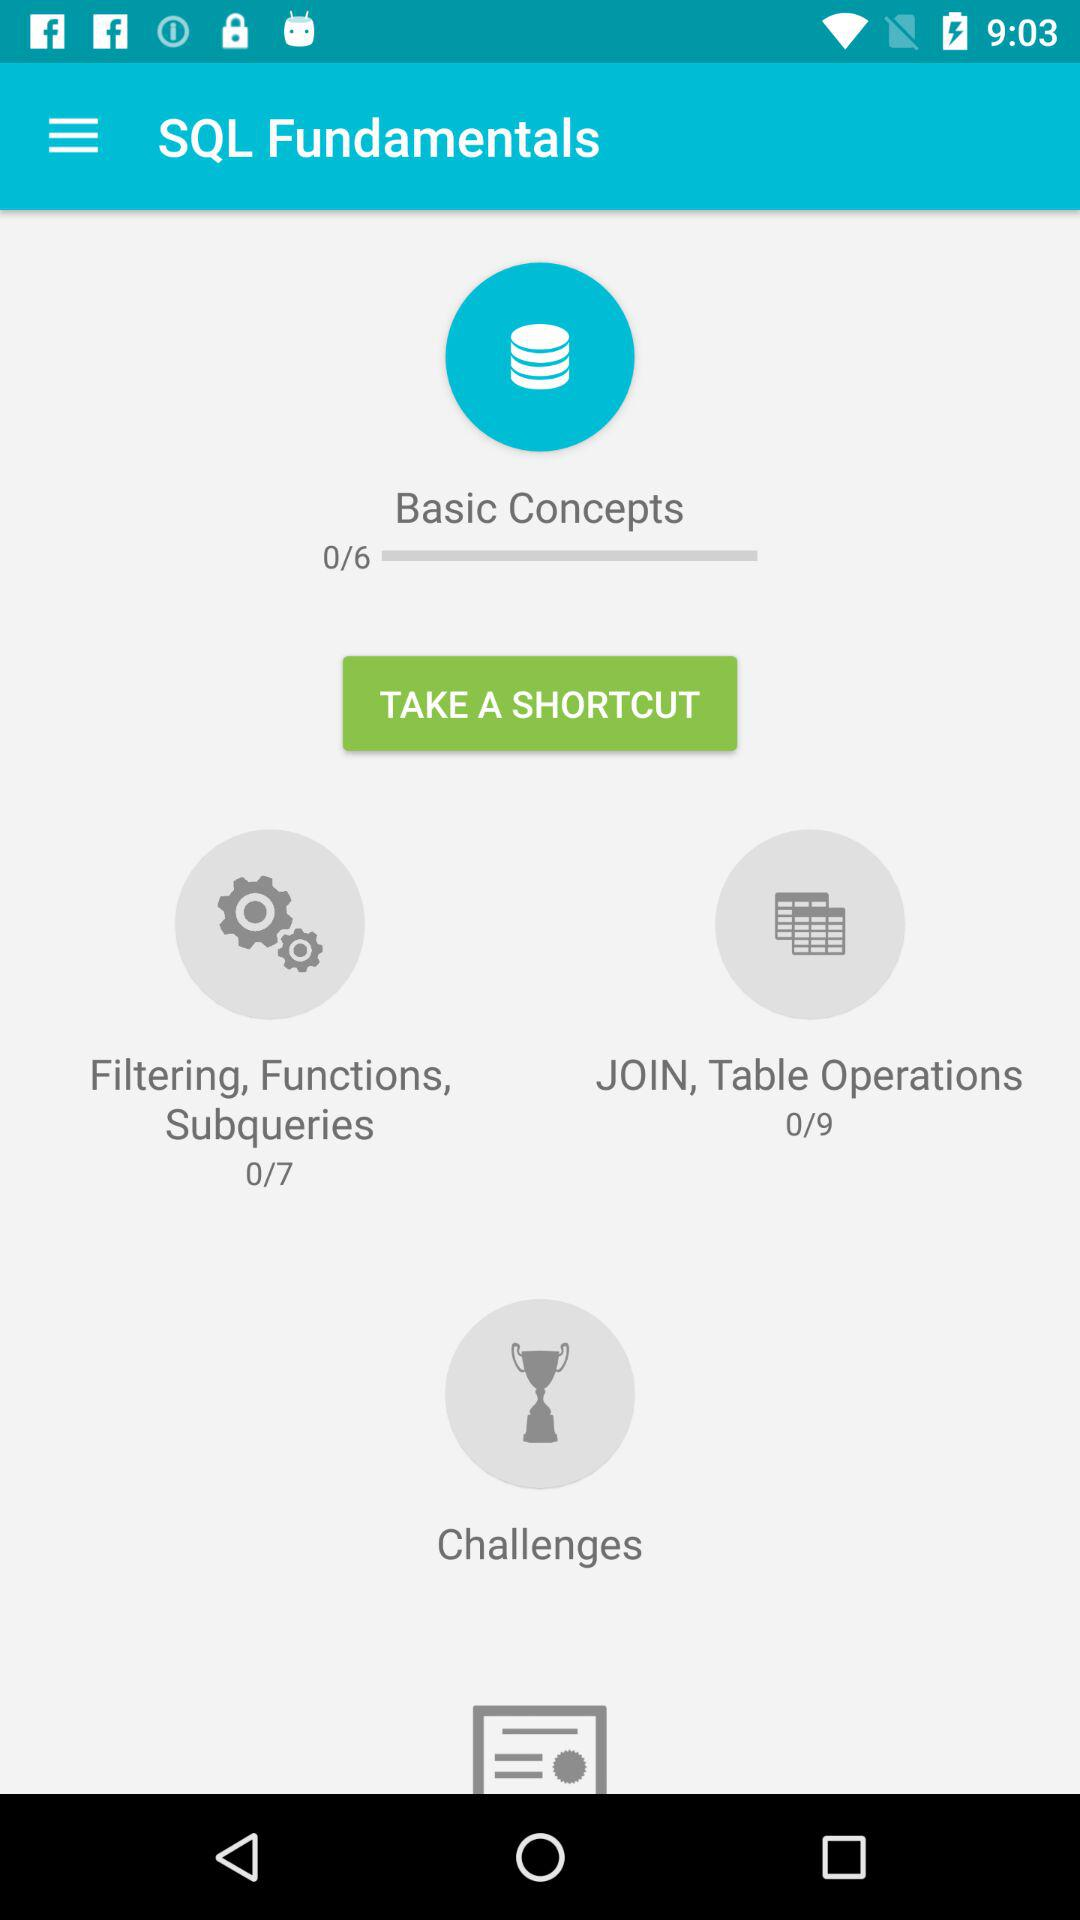How many chapters are there in "Basic Concepts"? There are 6 chapters in "Basic Concepts". 